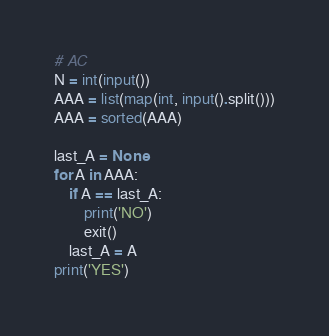Convert code to text. <code><loc_0><loc_0><loc_500><loc_500><_Python_># AC
N = int(input())
AAA = list(map(int, input().split()))
AAA = sorted(AAA)

last_A = None
for A in AAA:
    if A == last_A:
        print('NO')
        exit()
    last_A = A
print('YES')
</code> 